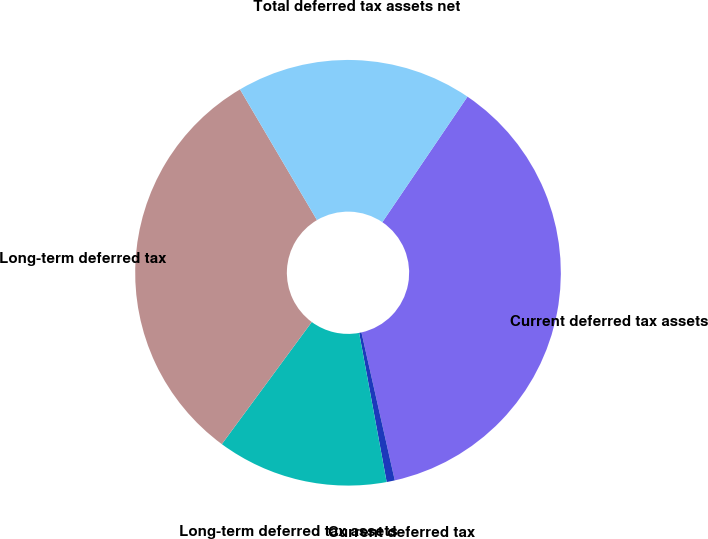<chart> <loc_0><loc_0><loc_500><loc_500><pie_chart><fcel>Current deferred tax assets<fcel>Current deferred tax<fcel>Long-term deferred tax assets<fcel>Long-term deferred tax<fcel>Total deferred tax assets net<nl><fcel>36.99%<fcel>0.62%<fcel>13.01%<fcel>31.43%<fcel>17.96%<nl></chart> 